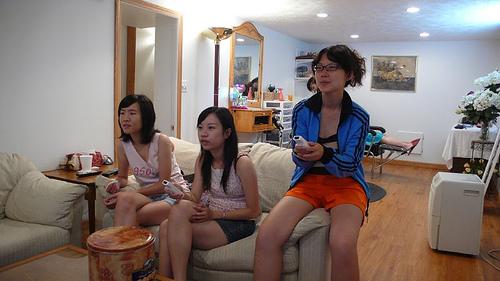How many girls are wearing glasses?
Short answer required. 1. How many people are in the picture?
Give a very brief answer. 3. Are this people playing?
Give a very brief answer. Yes. Which women does not have a name tag?
Concise answer only. All of them. What color hair does the lady sitting down have?
Answer briefly. Black. What color are the flowers?
Be succinct. White. 